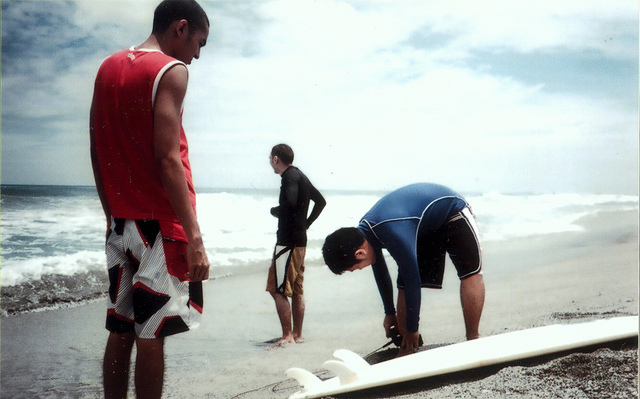Can you tell me about the fashion choices of the individuals in the picture? Certainly, the individual on the left is wearing a red sleeveless tank top paired with patterned board shorts, which is a common casual beachwear ensemble. The middle person is donning a black wetsuit, a practical choice for maintaining body temperature while in cooler waters. The person adjusting the surfboard is wearing a blue wetsuit top and black shorts, a combination allowing for flexibility and warmth. All seem to have opted for apparel that combines functionality with the leisurely aesthetic typical of surfing culture. 